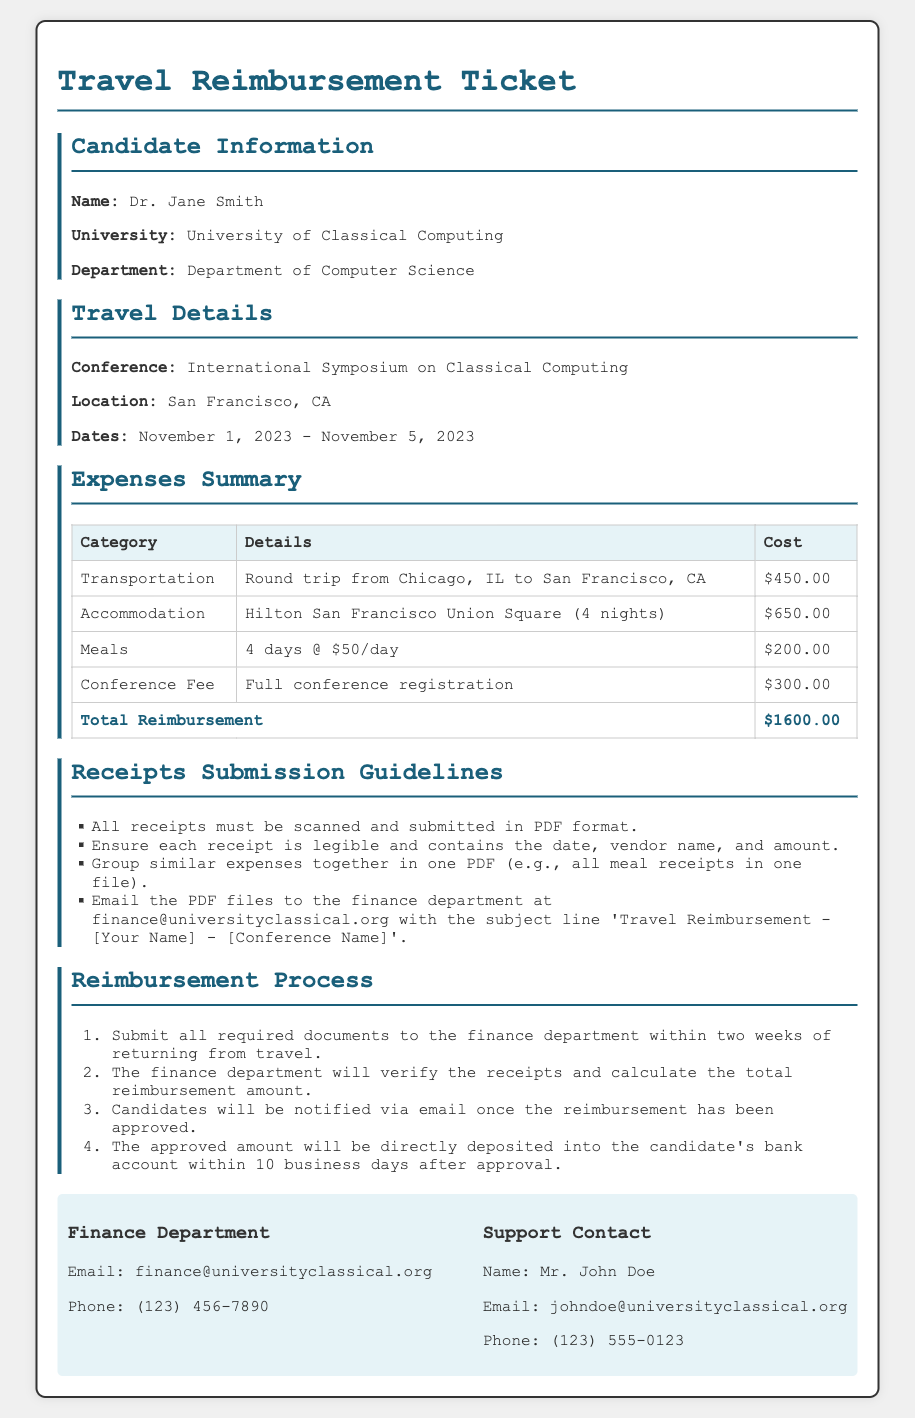What is the candidate's name? The document states the candidate's name as Dr. Jane Smith.
Answer: Dr. Jane Smith What is the total reimbursement amount? The total reimbursement is given as $1600.00 in the expenses summary.
Answer: $1600.00 How many nights was the accommodation for? The accommodation details indicate that it was for 4 nights.
Answer: 4 nights What is the email address of the finance department? The email address for the finance department is provided in the contact information as finance@universityclassical.org.
Answer: finance@universityclassical.org What is the location of the conference? The document lists the location of the conference as San Francisco, CA.
Answer: San Francisco, CA How long do candidates have to submit their documents after returning? The document specifies that candidates must submit documents within two weeks after travel.
Answer: Two weeks What type of receipts must be submitted? The receipt submission guidelines indicate that all receipts must be in PDF format.
Answer: PDF format What is the conference fee amount? The expenses summary outlines the conference fee as $300.00.
Answer: $300.00 Who should the receipts be emailed to? The guidelines specify that receipts should be emailed to the finance department.
Answer: Finance department 